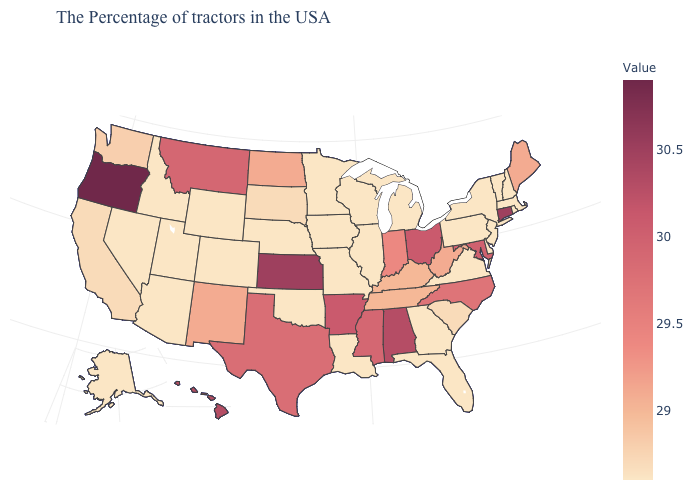Which states have the highest value in the USA?
Concise answer only. Oregon. Does Nevada have the lowest value in the West?
Answer briefly. Yes. Among the states that border Nebraska , which have the lowest value?
Be succinct. Missouri, Iowa, Wyoming, Colorado. Among the states that border Maine , which have the lowest value?
Short answer required. New Hampshire. Among the states that border Minnesota , which have the lowest value?
Write a very short answer. Wisconsin, Iowa. Among the states that border Virginia , which have the lowest value?
Keep it brief. Kentucky, Tennessee. Which states have the lowest value in the USA?
Answer briefly. Massachusetts, Rhode Island, New Hampshire, Vermont, New York, New Jersey, Delaware, Pennsylvania, Virginia, Florida, Georgia, Michigan, Wisconsin, Illinois, Louisiana, Missouri, Minnesota, Iowa, Nebraska, Oklahoma, Wyoming, Colorado, Utah, Arizona, Idaho, Nevada, Alaska. Does Utah have the highest value in the USA?
Write a very short answer. No. 